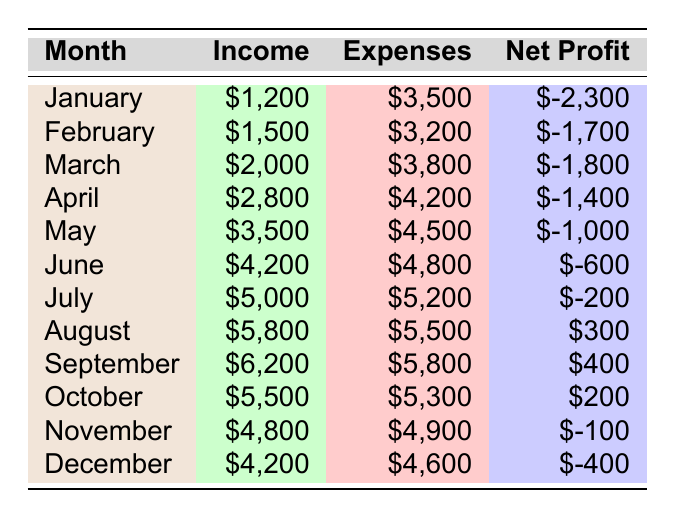What was the highest income month? By examining the "Income" column, August has the highest income at $5,800.
Answer: August What were the total expenses for the entire year? To find the total expenses, sum up all the values in the "Expenses" column: 3500 + 3200 + 3800 + 4200 + 4500 + 4800 + 5200 + 5500 + 5800 + 5300 + 4900 + 4600 = 59,300.
Answer: $59,300 In which month did the farmer first achieve a net profit? Looking at the "Net Profit" column, August is the first month with a positive net profit of $300.
Answer: August What is the average net profit for the months with a positive net profit? The months with a positive net profit are August, September, and October. Their net profits are 300, 400, and 200, respectively. Their average is (300 + 400 + 200) / 3 = 300.
Answer: 300 Was there any month where the income was greater than $5,000 but the net profit was negative? Checking the "Income" against the "Net Profit", in July the income was $5,000 with a net profit of -200, which fits the criteria.
Answer: Yes How much less were the total income compared to the total expenses for the year? The total income is $46,700 (sum of all income) and total expenses are $59,300. The difference is $59,300 - $46,700 = $12,600.
Answer: $12,600 In which month did expenses exceed income by the largest amount? Looking at the net profit values, January had expenses exceed income by $2,300, which is the largest gap.
Answer: January If the expenses for August were reduced by $1,000, what would the new net profit be for that month? August's original net profit was $300. With the expenses reduced by $1,000, the new expenses would be $4,500, resulting in a new net profit of $5,800 - $4,500 = $1,300.
Answer: $1,300 What is the median net profit of the year? Listing all net profits in order: -2,300, -1,700, -1,800, -1,400, -1,000, -600, -200, 300, 400, 200, -100, -400 gives us the middle two values (-200, 300), so the median is (-200 + 300) / 2 = 50.
Answer: 50 Did the farmer manage to earn a net profit in any month during the second half of the year? Reviewing the second half (July to December), the only months with a positive net profit are August, September, and October, confirming that net profits were achieved.
Answer: Yes 